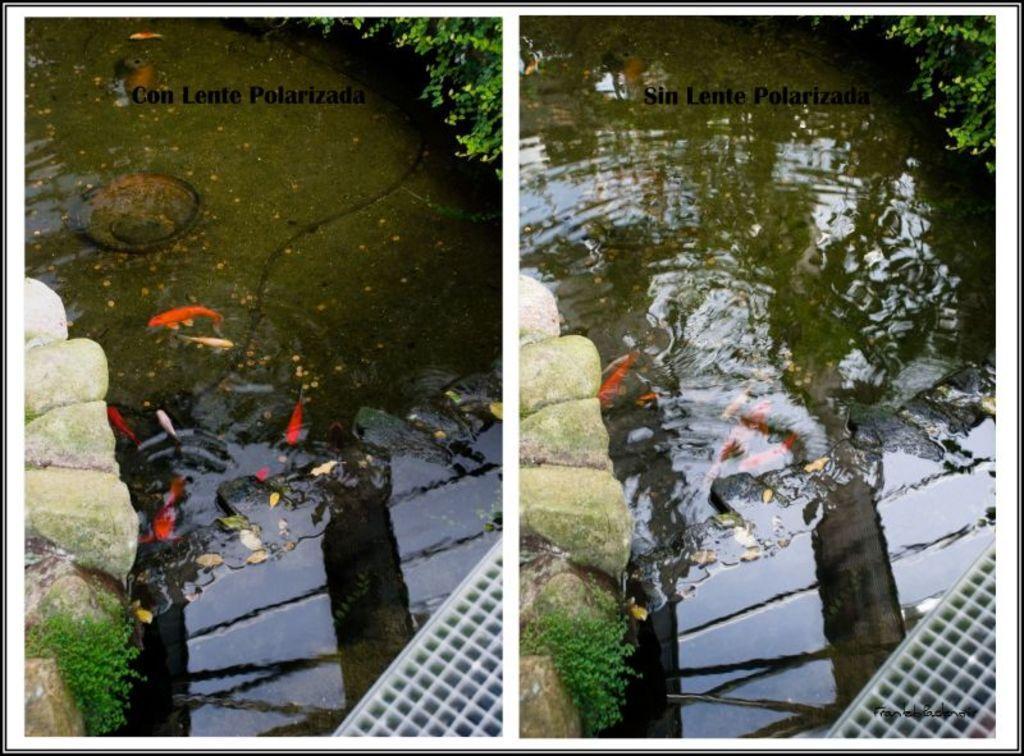Please provide a concise description of this image. In this image we can see the rocks on the left side of the image, water in the middle and at the top right hand corner we can see the plant. 